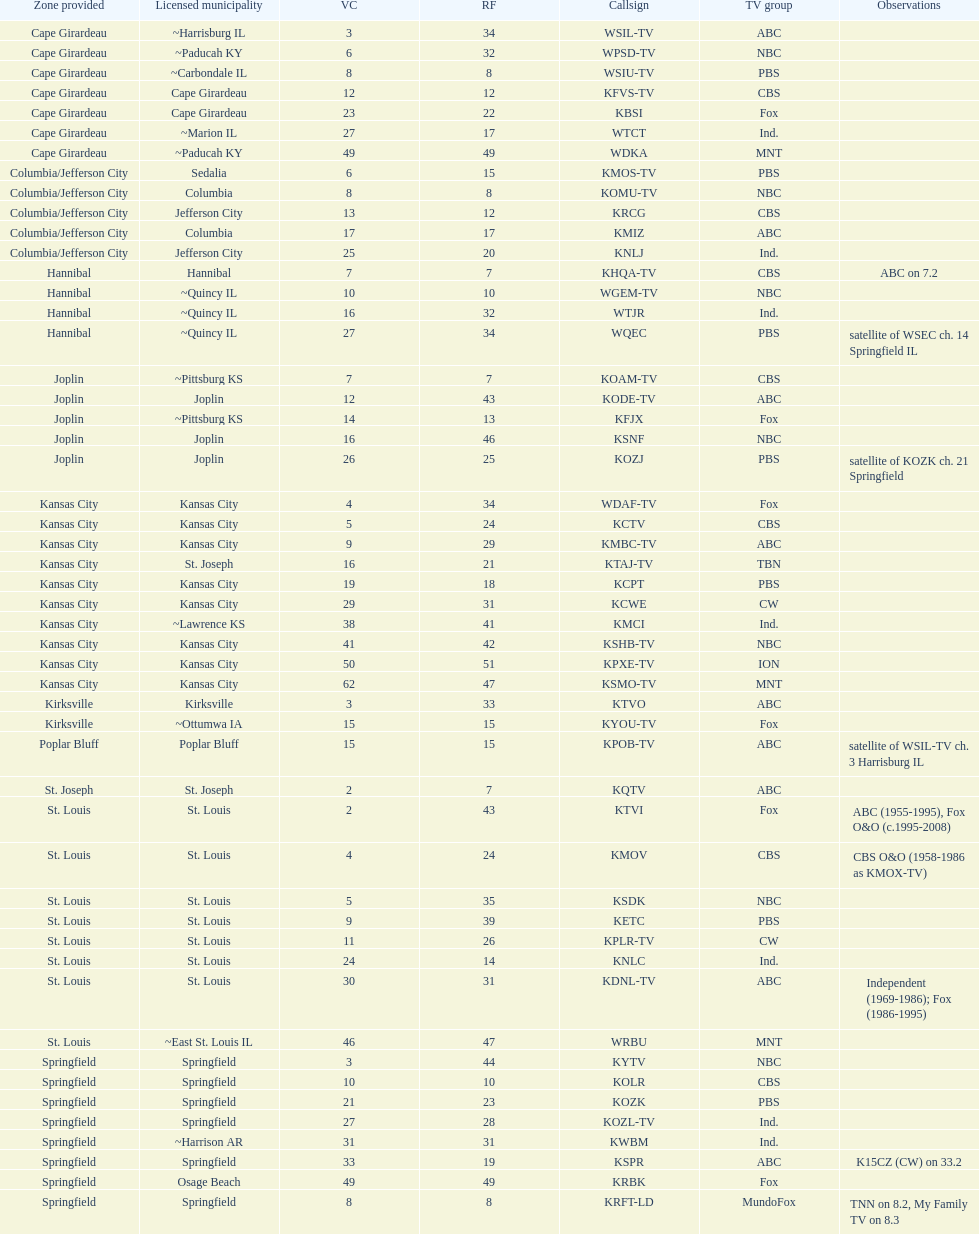Which station is licensed in the same city as koam-tv? KFJX. 